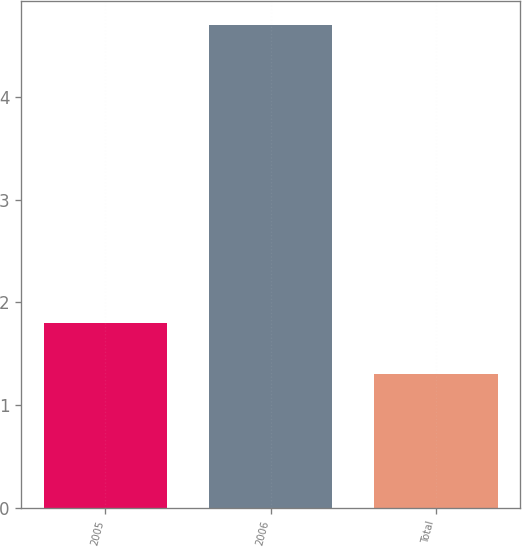Convert chart. <chart><loc_0><loc_0><loc_500><loc_500><bar_chart><fcel>2005<fcel>2006<fcel>Total<nl><fcel>1.8<fcel>4.7<fcel>1.3<nl></chart> 